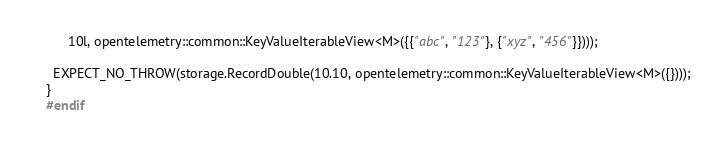<code> <loc_0><loc_0><loc_500><loc_500><_C++_>      10l, opentelemetry::common::KeyValueIterableView<M>({{"abc", "123"}, {"xyz", "456"}})));

  EXPECT_NO_THROW(storage.RecordDouble(10.10, opentelemetry::common::KeyValueIterableView<M>({})));
}
#endif
</code> 